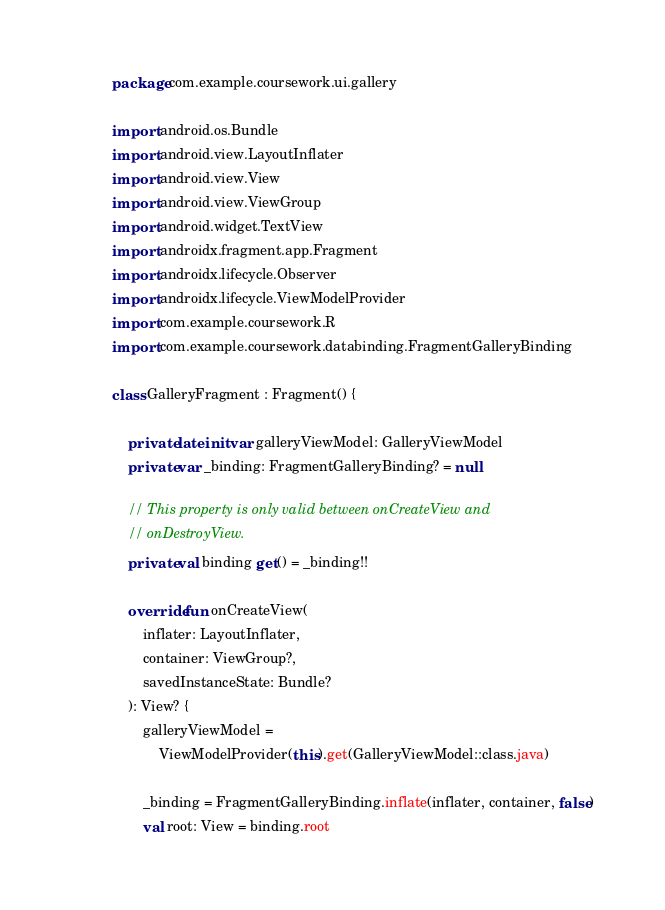Convert code to text. <code><loc_0><loc_0><loc_500><loc_500><_Kotlin_>package com.example.coursework.ui.gallery

import android.os.Bundle
import android.view.LayoutInflater
import android.view.View
import android.view.ViewGroup
import android.widget.TextView
import androidx.fragment.app.Fragment
import androidx.lifecycle.Observer
import androidx.lifecycle.ViewModelProvider
import com.example.coursework.R
import com.example.coursework.databinding.FragmentGalleryBinding

class GalleryFragment : Fragment() {

    private lateinit var galleryViewModel: GalleryViewModel
    private var _binding: FragmentGalleryBinding? = null

    // This property is only valid between onCreateView and
    // onDestroyView.
    private val binding get() = _binding!!

    override fun onCreateView(
        inflater: LayoutInflater,
        container: ViewGroup?,
        savedInstanceState: Bundle?
    ): View? {
        galleryViewModel =
            ViewModelProvider(this).get(GalleryViewModel::class.java)

        _binding = FragmentGalleryBinding.inflate(inflater, container, false)
        val root: View = binding.root
</code> 